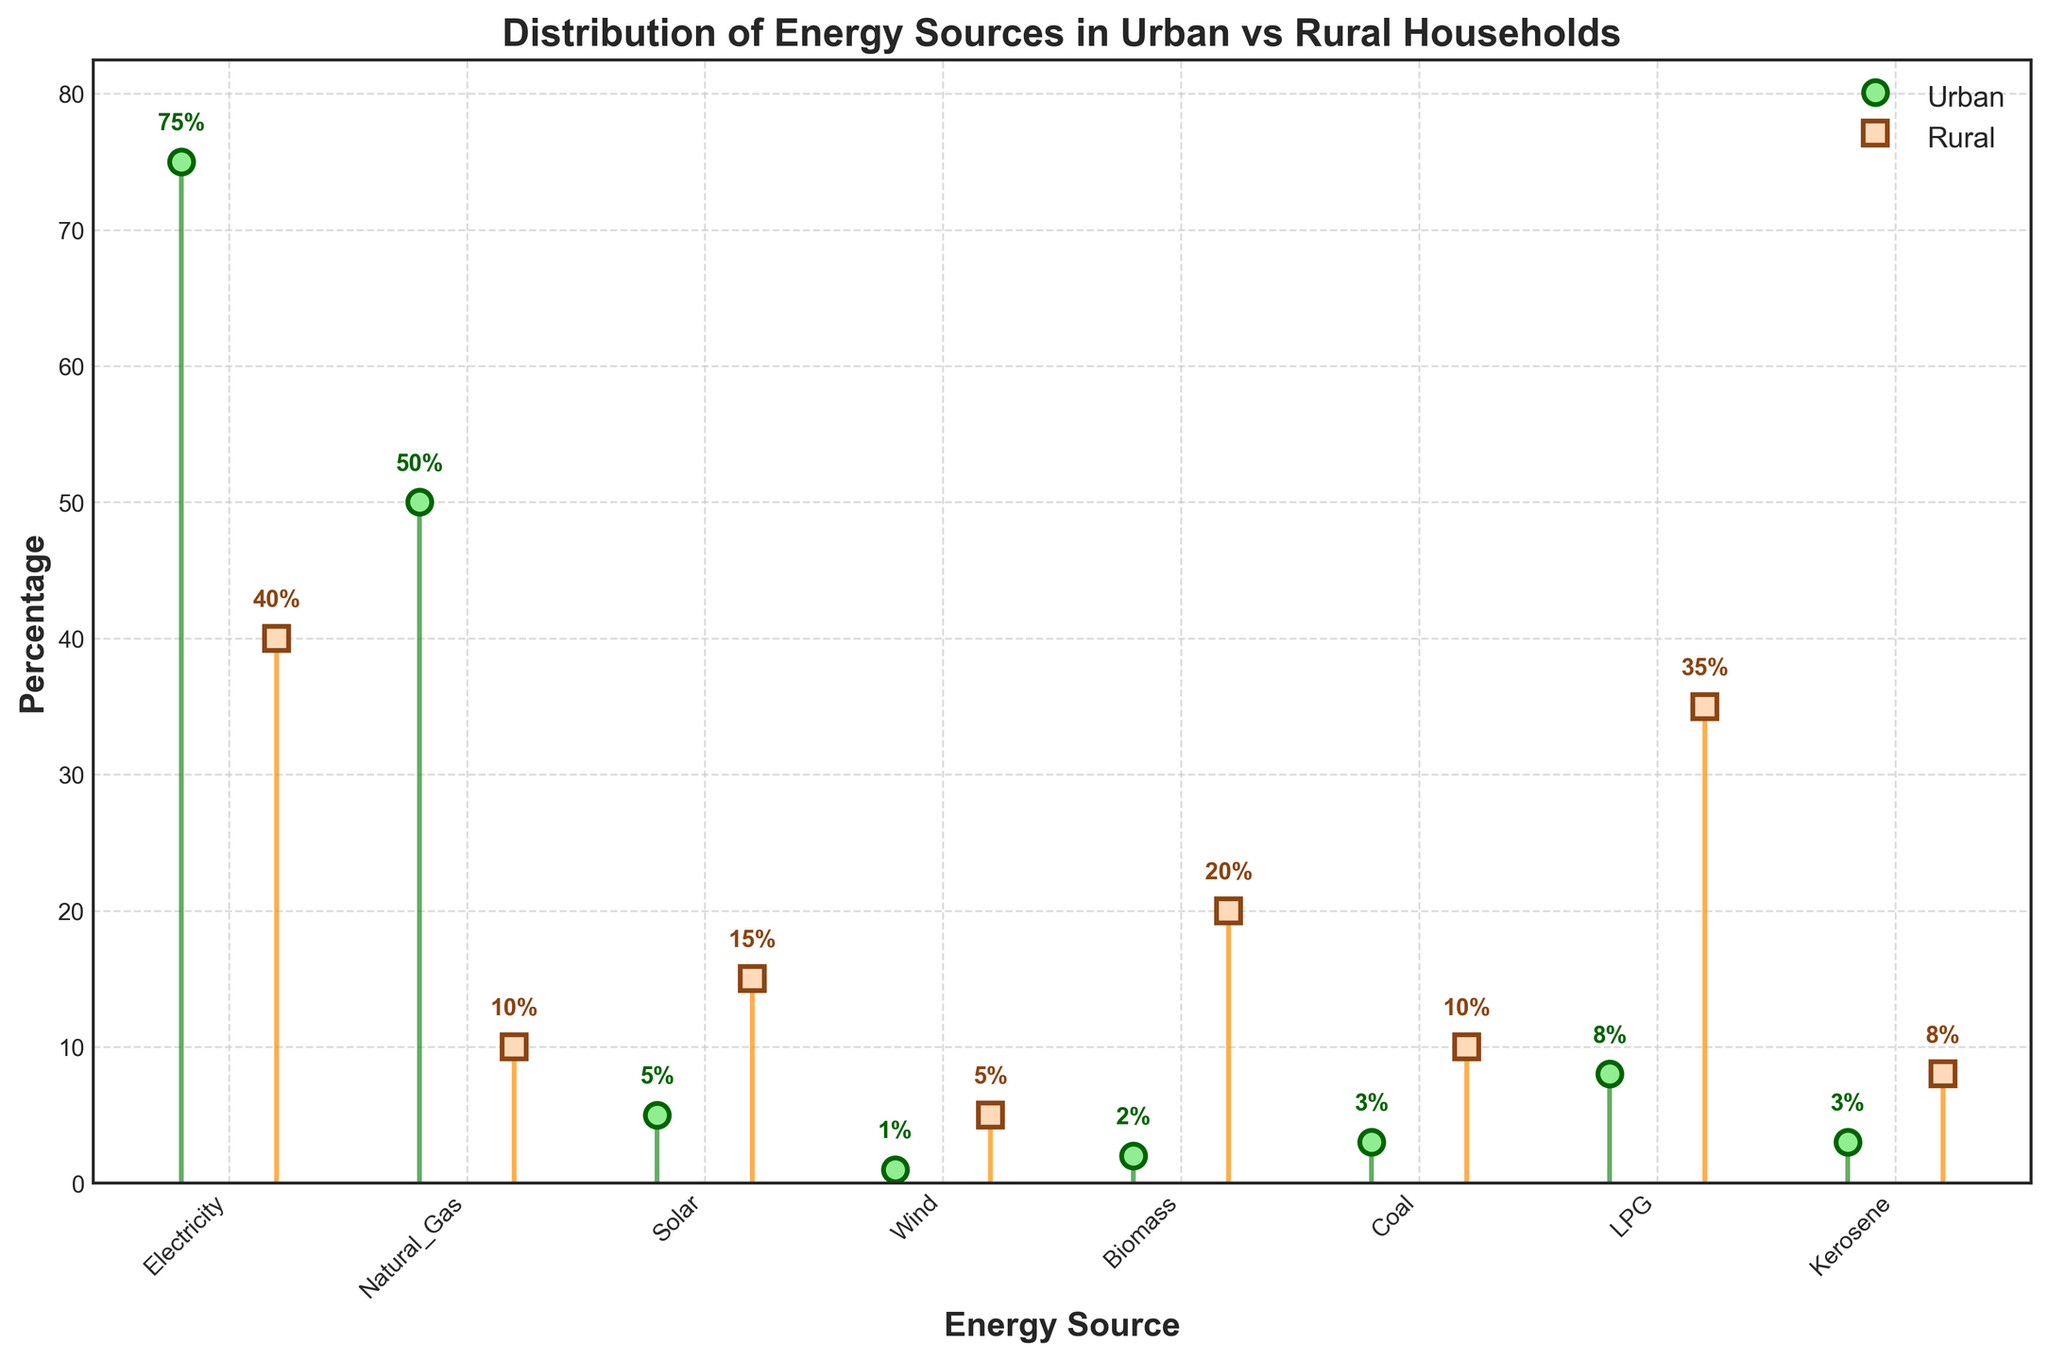What is the title of the figure? The title is located at the top of the figure and usually provides an overview of the content being displayed. In this case, the title is "Distribution of Energy Sources in Urban vs Rural Households."
Answer: Distribution of Energy Sources in Urban vs Rural Households Which energy source has the highest usage in urban households? By looking at the highest point of the green markers (which represent urban households), it is clear that the energy source with the highest usage is "Electricity." The corresponding percentage for "Electricity" is 75%.
Answer: Electricity What are the percentages of Urban and Rural households using Solar energy? Locate the points that represent Solar energy on the x-axis. The green marker (urban) is at 5%, and the orange marker (rural) is at 15%. The percentages are thus 5% for urban and 15% for rural households.
Answer: 5% (Urban), 15% (Rural) Which energy source has a greater difference in usage between urban and rural households? To find this, we need to calculate the absolute differences for each energy source. The source with the largest difference is "Electricity" with an absolute difference of 75% - 40% = 35%.
Answer: Electricity What is the combined percentage of rural households using Biomass and Coal? Add the percentages for Biomass (20%) and Coal (10%) in rural households. The combined percentage is 20% + 10% = 30%.
Answer: 30% Which energy source shows a relatively similar usage percentage between urban and rural households? Look for energy sources where the green and orange markers are close to each other. "Kerosene" seems to be used relatively similarly, with urban at 3% and rural at 8%. The difference is 5%, which is one of the smallest differences.
Answer: Kerosene What percentage of urban households use Natural Gas, and how does it compare to rural households? From the figure, urban households have a 50% usage rate for Natural Gas, while rural households have a 10% usage rate. The urban percentage is 40% higher than the rural percentage.
Answer: 50% (Urban), 40% higher Which energy sources are used more in rural households than in urban households? Identify the energy sources where the orange marker is higher than the green marker. These sources are Solar, Wind, Biomass, and Coal.
Answer: Solar, Wind, Biomass, Coal What is the average usage percentage of LPG in urban and rural households? The percentages for LPG are 8% for urban and 35% for rural. The average is calculated as (8% + 35%) / 2 = 21.5%.
Answer: 21.5% 